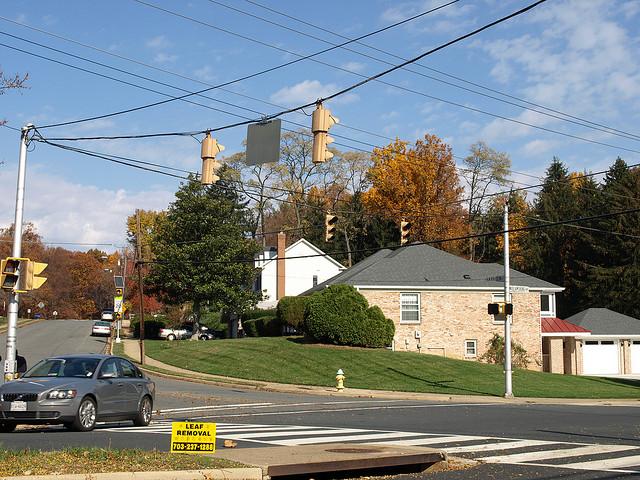Is this a summertime scene?
Answer briefly. Yes. How many cars are on the road?
Concise answer only. 1. Is this a two way street?
Write a very short answer. Yes. Why doesn't the first car have their headlights on?
Short answer required. Daytime. 